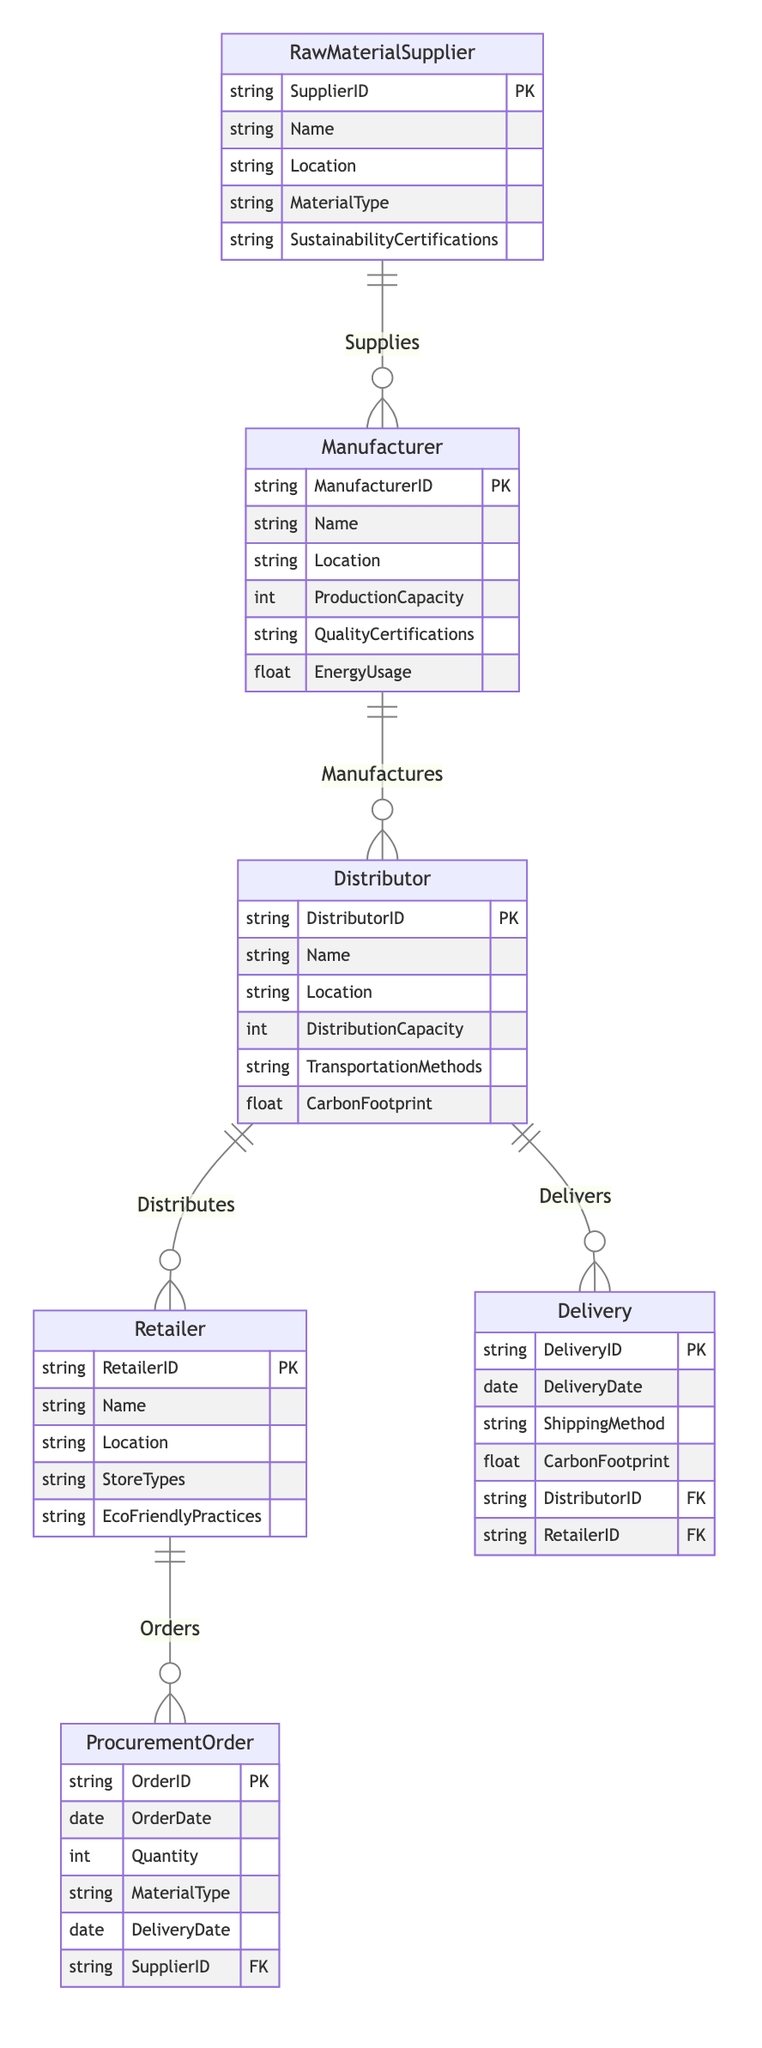What are the attributes of the Manufacturer entity? The Manufacturer entity has the following attributes: ManufacturerID, Name, Location, ProductionCapacity, QualityCertifications, and EnergyUsage, which can be identified directly from the diagram.
Answer: ManufacturerID, Name, Location, ProductionCapacity, QualityCertifications, EnergyUsage How many entities are present in the diagram? There are six entities represented in the diagram: RawMaterialSupplier, Manufacturer, Distributor, Retailer, ProcurementOrder, and Delivery. Counting these reveals that the total is six.
Answer: 6 Which entity is linked with the Supplies relationship? The Supplies relationship connects the RawMaterialSupplier entity with the Manufacturer entity, as indicated in the diagram by the relationship line.
Answer: Manufacturer What is the primary key of the Retailer entity? The primary key of the Retailer entity is RetailerID, which is explicitly mentioned in the attributes section of the Retailer in the diagram.
Answer: RetailerID Which relationship does the Distributor participate in for Deliveries? The Distributor participates in the Delivers relationship with the Delivery entity, as shown in the connections of the diagram where the Distributor connects to Delivery.
Answer: Delivers What is the relationship between Retailer and ProcurementOrder? The Retailer entity has an Orders relationship with the ProcurementOrder entity, which is indicated by the connecting line showing the relationship in the diagram.
Answer: Orders Explain how raw materials are acquired by manufacturers? Manufacturers acquire raw materials through the Supplies relationship, where RawMaterialSuppliers provide materials to Manufacturers. This relationship emphasizes the flow from suppliers to manufacturers in the diagram.
Answer: Supplies What is the significance of CarbonFootprint in the Distributor entity? CarbonFootprint is an attribute of the Distributor that quantifies its environmental impact concerning transportation and distribution methods, useful in assessing sustainability performance as shown in the attributes of the Distributor.
Answer: Environmental impact Which entity’s attributes include TransportationMethods? The Distributor entity includes the attribute TransportationMethods, as detailed in its section, which identifies how goods are transported in the supply chain.
Answer: Distributor 